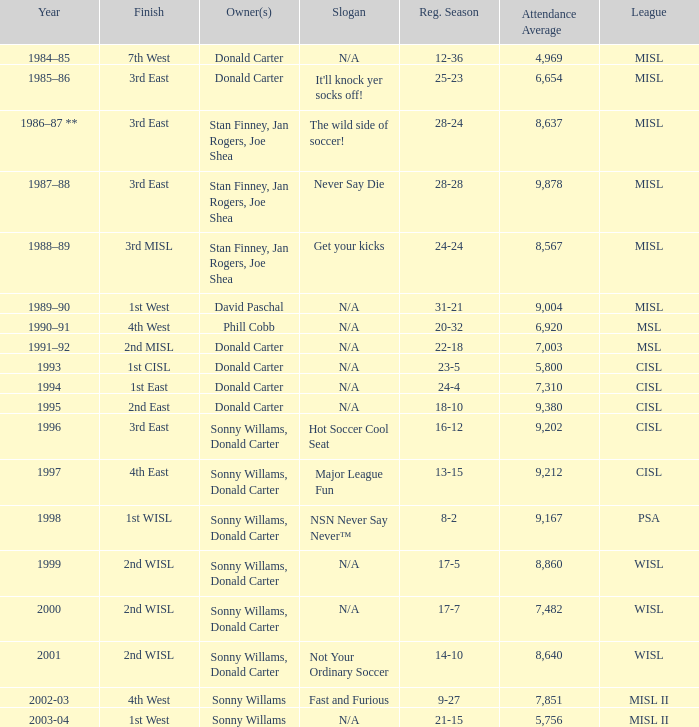What year has the wild side of soccer! as the slogan? 1986–87 **. 